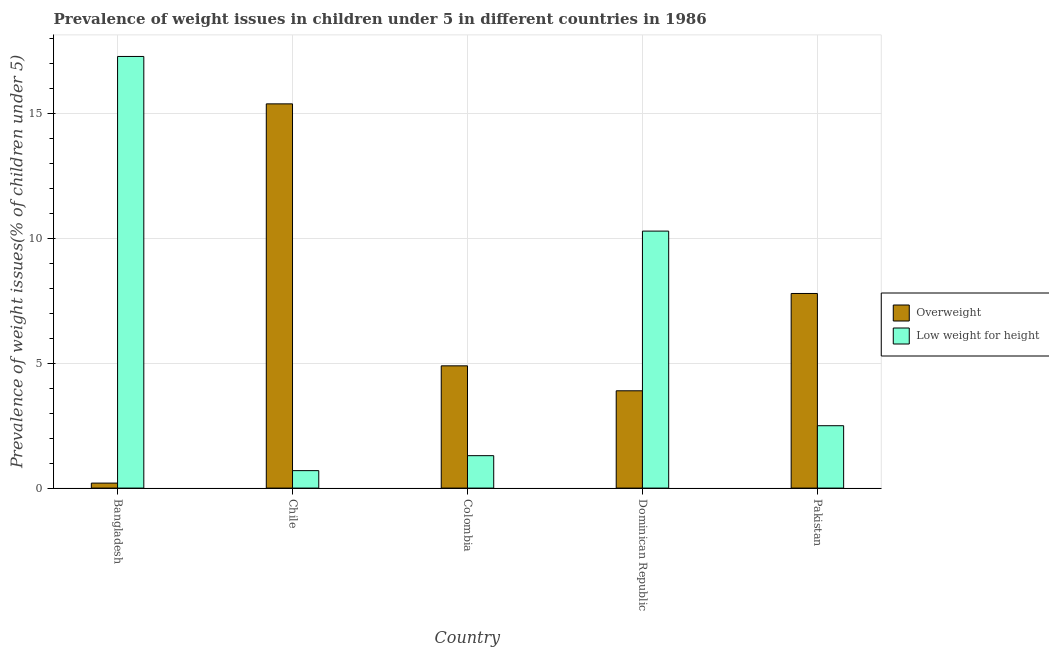How many different coloured bars are there?
Offer a very short reply. 2. Are the number of bars per tick equal to the number of legend labels?
Offer a terse response. Yes. Are the number of bars on each tick of the X-axis equal?
Provide a short and direct response. Yes. How many bars are there on the 2nd tick from the left?
Your response must be concise. 2. How many bars are there on the 5th tick from the right?
Your answer should be very brief. 2. In how many cases, is the number of bars for a given country not equal to the number of legend labels?
Keep it short and to the point. 0. What is the percentage of overweight children in Chile?
Your answer should be very brief. 15.4. Across all countries, what is the maximum percentage of underweight children?
Offer a very short reply. 17.3. Across all countries, what is the minimum percentage of overweight children?
Provide a short and direct response. 0.2. What is the total percentage of underweight children in the graph?
Give a very brief answer. 32.1. What is the difference between the percentage of underweight children in Chile and that in Dominican Republic?
Offer a very short reply. -9.6. What is the difference between the percentage of overweight children in Colombia and the percentage of underweight children in Dominican Republic?
Give a very brief answer. -5.4. What is the average percentage of overweight children per country?
Your response must be concise. 6.44. What is the difference between the percentage of underweight children and percentage of overweight children in Dominican Republic?
Provide a succinct answer. 6.4. In how many countries, is the percentage of underweight children greater than 16 %?
Ensure brevity in your answer.  1. What is the ratio of the percentage of underweight children in Bangladesh to that in Colombia?
Offer a very short reply. 13.31. Is the percentage of underweight children in Chile less than that in Dominican Republic?
Your answer should be very brief. Yes. What is the difference between the highest and the second highest percentage of underweight children?
Your response must be concise. 7. What is the difference between the highest and the lowest percentage of overweight children?
Offer a very short reply. 15.2. In how many countries, is the percentage of overweight children greater than the average percentage of overweight children taken over all countries?
Make the answer very short. 2. What does the 2nd bar from the left in Pakistan represents?
Give a very brief answer. Low weight for height. What does the 1st bar from the right in Chile represents?
Offer a terse response. Low weight for height. What is the difference between two consecutive major ticks on the Y-axis?
Make the answer very short. 5. What is the title of the graph?
Your response must be concise. Prevalence of weight issues in children under 5 in different countries in 1986. What is the label or title of the Y-axis?
Ensure brevity in your answer.  Prevalence of weight issues(% of children under 5). What is the Prevalence of weight issues(% of children under 5) of Overweight in Bangladesh?
Your answer should be compact. 0.2. What is the Prevalence of weight issues(% of children under 5) in Low weight for height in Bangladesh?
Your answer should be compact. 17.3. What is the Prevalence of weight issues(% of children under 5) of Overweight in Chile?
Your answer should be compact. 15.4. What is the Prevalence of weight issues(% of children under 5) of Low weight for height in Chile?
Ensure brevity in your answer.  0.7. What is the Prevalence of weight issues(% of children under 5) of Overweight in Colombia?
Offer a very short reply. 4.9. What is the Prevalence of weight issues(% of children under 5) of Low weight for height in Colombia?
Your response must be concise. 1.3. What is the Prevalence of weight issues(% of children under 5) in Overweight in Dominican Republic?
Make the answer very short. 3.9. What is the Prevalence of weight issues(% of children under 5) of Low weight for height in Dominican Republic?
Provide a short and direct response. 10.3. What is the Prevalence of weight issues(% of children under 5) of Overweight in Pakistan?
Provide a succinct answer. 7.8. Across all countries, what is the maximum Prevalence of weight issues(% of children under 5) in Overweight?
Provide a succinct answer. 15.4. Across all countries, what is the maximum Prevalence of weight issues(% of children under 5) in Low weight for height?
Make the answer very short. 17.3. Across all countries, what is the minimum Prevalence of weight issues(% of children under 5) of Overweight?
Make the answer very short. 0.2. Across all countries, what is the minimum Prevalence of weight issues(% of children under 5) of Low weight for height?
Give a very brief answer. 0.7. What is the total Prevalence of weight issues(% of children under 5) of Overweight in the graph?
Make the answer very short. 32.2. What is the total Prevalence of weight issues(% of children under 5) in Low weight for height in the graph?
Ensure brevity in your answer.  32.1. What is the difference between the Prevalence of weight issues(% of children under 5) in Overweight in Bangladesh and that in Chile?
Your answer should be compact. -15.2. What is the difference between the Prevalence of weight issues(% of children under 5) of Low weight for height in Bangladesh and that in Chile?
Offer a terse response. 16.6. What is the difference between the Prevalence of weight issues(% of children under 5) in Low weight for height in Bangladesh and that in Colombia?
Your answer should be compact. 16. What is the difference between the Prevalence of weight issues(% of children under 5) of Overweight in Bangladesh and that in Dominican Republic?
Make the answer very short. -3.7. What is the difference between the Prevalence of weight issues(% of children under 5) of Low weight for height in Bangladesh and that in Pakistan?
Your answer should be very brief. 14.8. What is the difference between the Prevalence of weight issues(% of children under 5) in Overweight in Chile and that in Colombia?
Make the answer very short. 10.5. What is the difference between the Prevalence of weight issues(% of children under 5) in Overweight in Chile and that in Dominican Republic?
Offer a terse response. 11.5. What is the difference between the Prevalence of weight issues(% of children under 5) in Overweight in Chile and that in Pakistan?
Provide a succinct answer. 7.6. What is the difference between the Prevalence of weight issues(% of children under 5) in Overweight in Colombia and that in Dominican Republic?
Provide a short and direct response. 1. What is the difference between the Prevalence of weight issues(% of children under 5) of Low weight for height in Colombia and that in Dominican Republic?
Offer a terse response. -9. What is the difference between the Prevalence of weight issues(% of children under 5) of Low weight for height in Colombia and that in Pakistan?
Your response must be concise. -1.2. What is the difference between the Prevalence of weight issues(% of children under 5) of Overweight in Bangladesh and the Prevalence of weight issues(% of children under 5) of Low weight for height in Chile?
Keep it short and to the point. -0.5. What is the difference between the Prevalence of weight issues(% of children under 5) in Overweight in Bangladesh and the Prevalence of weight issues(% of children under 5) in Low weight for height in Pakistan?
Your response must be concise. -2.3. What is the difference between the Prevalence of weight issues(% of children under 5) in Overweight in Colombia and the Prevalence of weight issues(% of children under 5) in Low weight for height in Dominican Republic?
Your answer should be compact. -5.4. What is the average Prevalence of weight issues(% of children under 5) in Overweight per country?
Keep it short and to the point. 6.44. What is the average Prevalence of weight issues(% of children under 5) in Low weight for height per country?
Ensure brevity in your answer.  6.42. What is the difference between the Prevalence of weight issues(% of children under 5) of Overweight and Prevalence of weight issues(% of children under 5) of Low weight for height in Bangladesh?
Ensure brevity in your answer.  -17.1. What is the difference between the Prevalence of weight issues(% of children under 5) of Overweight and Prevalence of weight issues(% of children under 5) of Low weight for height in Dominican Republic?
Give a very brief answer. -6.4. What is the difference between the Prevalence of weight issues(% of children under 5) of Overweight and Prevalence of weight issues(% of children under 5) of Low weight for height in Pakistan?
Your answer should be very brief. 5.3. What is the ratio of the Prevalence of weight issues(% of children under 5) in Overweight in Bangladesh to that in Chile?
Provide a short and direct response. 0.01. What is the ratio of the Prevalence of weight issues(% of children under 5) of Low weight for height in Bangladesh to that in Chile?
Keep it short and to the point. 24.71. What is the ratio of the Prevalence of weight issues(% of children under 5) in Overweight in Bangladesh to that in Colombia?
Provide a succinct answer. 0.04. What is the ratio of the Prevalence of weight issues(% of children under 5) in Low weight for height in Bangladesh to that in Colombia?
Offer a very short reply. 13.31. What is the ratio of the Prevalence of weight issues(% of children under 5) of Overweight in Bangladesh to that in Dominican Republic?
Give a very brief answer. 0.05. What is the ratio of the Prevalence of weight issues(% of children under 5) in Low weight for height in Bangladesh to that in Dominican Republic?
Your answer should be compact. 1.68. What is the ratio of the Prevalence of weight issues(% of children under 5) in Overweight in Bangladesh to that in Pakistan?
Your response must be concise. 0.03. What is the ratio of the Prevalence of weight issues(% of children under 5) in Low weight for height in Bangladesh to that in Pakistan?
Your response must be concise. 6.92. What is the ratio of the Prevalence of weight issues(% of children under 5) of Overweight in Chile to that in Colombia?
Ensure brevity in your answer.  3.14. What is the ratio of the Prevalence of weight issues(% of children under 5) in Low weight for height in Chile to that in Colombia?
Your response must be concise. 0.54. What is the ratio of the Prevalence of weight issues(% of children under 5) in Overweight in Chile to that in Dominican Republic?
Provide a succinct answer. 3.95. What is the ratio of the Prevalence of weight issues(% of children under 5) of Low weight for height in Chile to that in Dominican Republic?
Provide a succinct answer. 0.07. What is the ratio of the Prevalence of weight issues(% of children under 5) of Overweight in Chile to that in Pakistan?
Keep it short and to the point. 1.97. What is the ratio of the Prevalence of weight issues(% of children under 5) in Low weight for height in Chile to that in Pakistan?
Give a very brief answer. 0.28. What is the ratio of the Prevalence of weight issues(% of children under 5) in Overweight in Colombia to that in Dominican Republic?
Offer a very short reply. 1.26. What is the ratio of the Prevalence of weight issues(% of children under 5) of Low weight for height in Colombia to that in Dominican Republic?
Provide a short and direct response. 0.13. What is the ratio of the Prevalence of weight issues(% of children under 5) of Overweight in Colombia to that in Pakistan?
Offer a terse response. 0.63. What is the ratio of the Prevalence of weight issues(% of children under 5) in Low weight for height in Colombia to that in Pakistan?
Ensure brevity in your answer.  0.52. What is the ratio of the Prevalence of weight issues(% of children under 5) in Low weight for height in Dominican Republic to that in Pakistan?
Offer a terse response. 4.12. What is the difference between the highest and the second highest Prevalence of weight issues(% of children under 5) in Overweight?
Your response must be concise. 7.6. What is the difference between the highest and the second highest Prevalence of weight issues(% of children under 5) of Low weight for height?
Your answer should be compact. 7. What is the difference between the highest and the lowest Prevalence of weight issues(% of children under 5) of Low weight for height?
Make the answer very short. 16.6. 